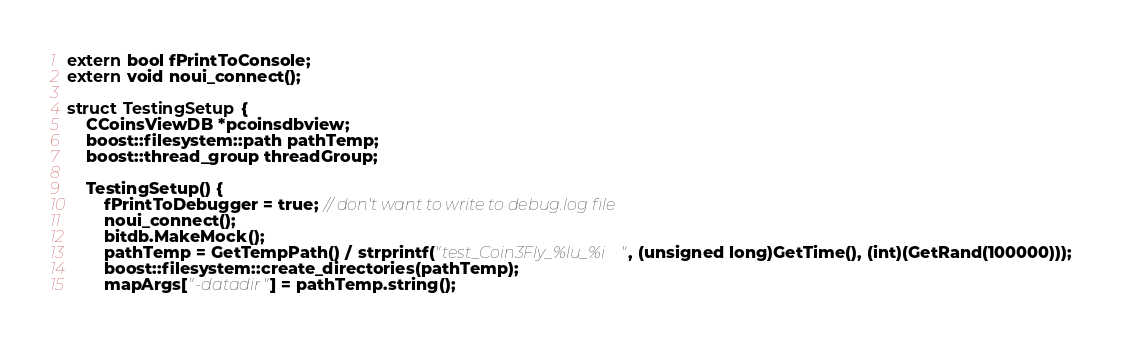<code> <loc_0><loc_0><loc_500><loc_500><_C++_>
extern bool fPrintToConsole;
extern void noui_connect();

struct TestingSetup {
    CCoinsViewDB *pcoinsdbview;
    boost::filesystem::path pathTemp;
    boost::thread_group threadGroup;

    TestingSetup() {
        fPrintToDebugger = true; // don't want to write to debug.log file
        noui_connect();
        bitdb.MakeMock();
        pathTemp = GetTempPath() / strprintf("test_Coin3Fly_%lu_%i", (unsigned long)GetTime(), (int)(GetRand(100000)));
        boost::filesystem::create_directories(pathTemp);
        mapArgs["-datadir"] = pathTemp.string();</code> 